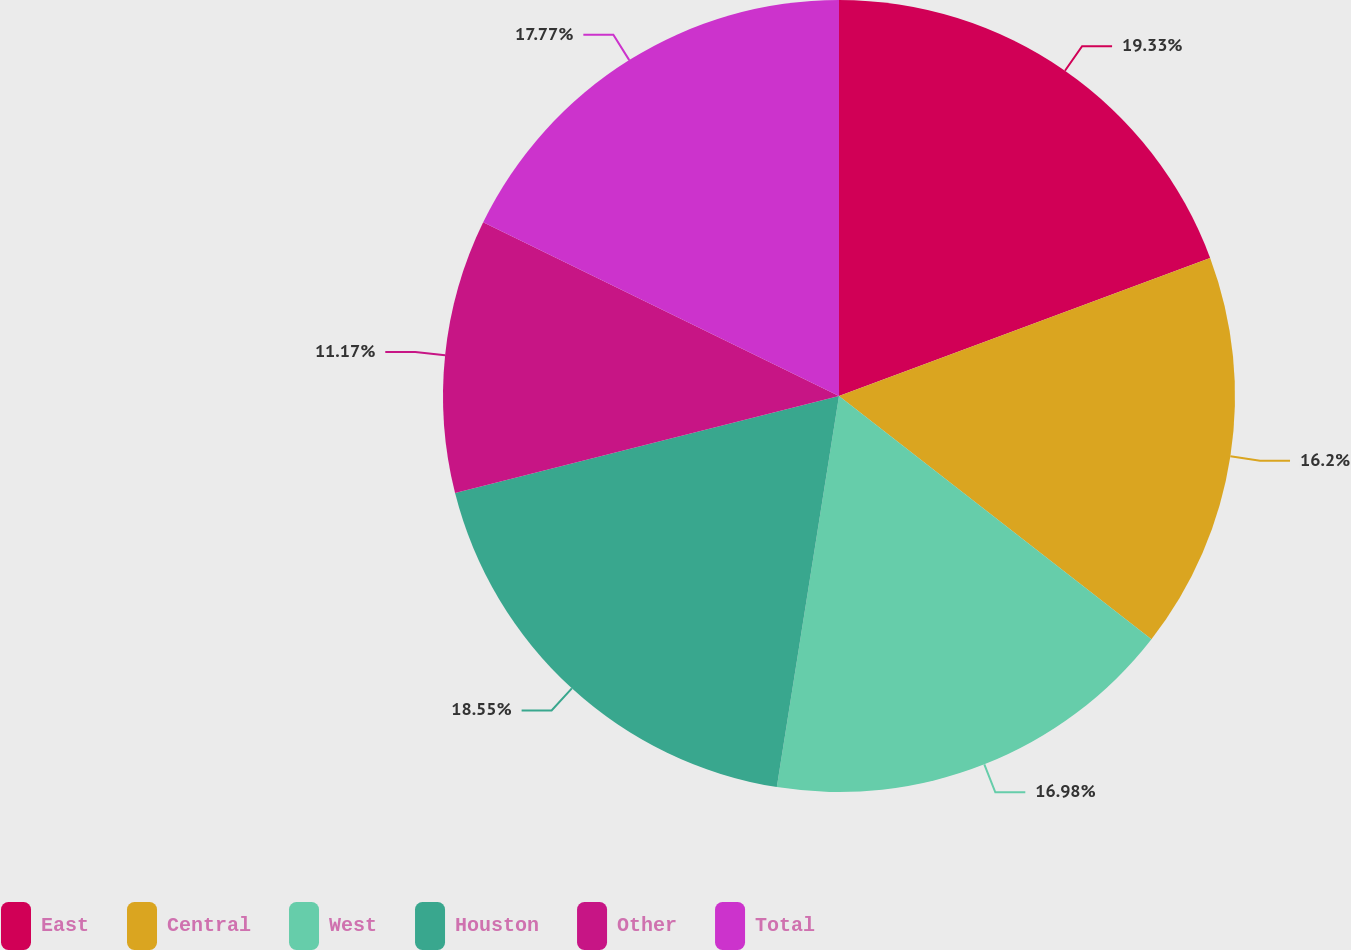Convert chart. <chart><loc_0><loc_0><loc_500><loc_500><pie_chart><fcel>East<fcel>Central<fcel>West<fcel>Houston<fcel>Other<fcel>Total<nl><fcel>19.33%<fcel>16.2%<fcel>16.98%<fcel>18.55%<fcel>11.17%<fcel>17.77%<nl></chart> 